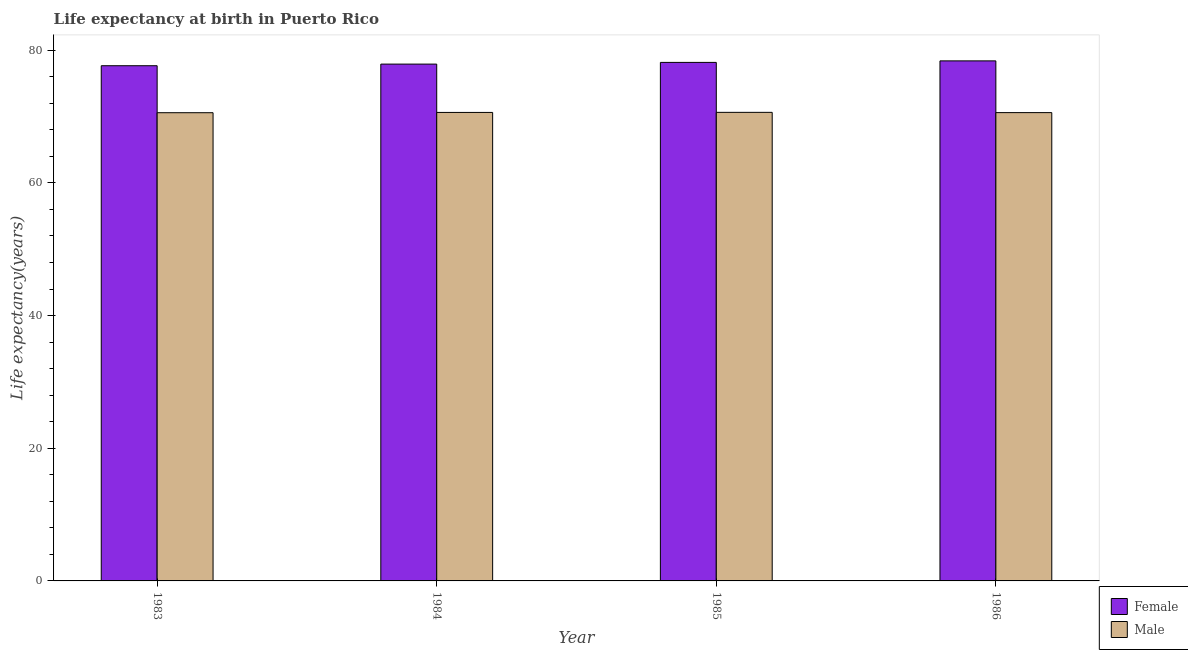How many groups of bars are there?
Your response must be concise. 4. What is the label of the 2nd group of bars from the left?
Your answer should be very brief. 1984. What is the life expectancy(male) in 1984?
Provide a succinct answer. 70.62. Across all years, what is the maximum life expectancy(female)?
Your response must be concise. 78.39. Across all years, what is the minimum life expectancy(male)?
Offer a terse response. 70.58. What is the total life expectancy(male) in the graph?
Give a very brief answer. 282.44. What is the difference between the life expectancy(female) in 1984 and that in 1985?
Provide a succinct answer. -0.26. What is the difference between the life expectancy(male) in 1986 and the life expectancy(female) in 1984?
Offer a very short reply. -0.03. What is the average life expectancy(male) per year?
Provide a succinct answer. 70.61. In the year 1984, what is the difference between the life expectancy(female) and life expectancy(male)?
Your answer should be very brief. 0. What is the ratio of the life expectancy(female) in 1983 to that in 1985?
Make the answer very short. 0.99. Is the difference between the life expectancy(male) in 1985 and 1986 greater than the difference between the life expectancy(female) in 1985 and 1986?
Keep it short and to the point. No. What is the difference between the highest and the second highest life expectancy(female)?
Keep it short and to the point. 0.23. What is the difference between the highest and the lowest life expectancy(male)?
Offer a terse response. 0.05. In how many years, is the life expectancy(male) greater than the average life expectancy(male) taken over all years?
Provide a short and direct response. 2. What does the 1st bar from the left in 1985 represents?
Ensure brevity in your answer.  Female. What does the 1st bar from the right in 1983 represents?
Provide a short and direct response. Male. Are all the bars in the graph horizontal?
Keep it short and to the point. No. What is the difference between two consecutive major ticks on the Y-axis?
Your response must be concise. 20. Are the values on the major ticks of Y-axis written in scientific E-notation?
Offer a very short reply. No. Does the graph contain grids?
Provide a short and direct response. No. How many legend labels are there?
Provide a short and direct response. 2. How are the legend labels stacked?
Offer a very short reply. Vertical. What is the title of the graph?
Ensure brevity in your answer.  Life expectancy at birth in Puerto Rico. What is the label or title of the Y-axis?
Offer a terse response. Life expectancy(years). What is the Life expectancy(years) of Female in 1983?
Ensure brevity in your answer.  77.66. What is the Life expectancy(years) in Male in 1983?
Offer a terse response. 70.58. What is the Life expectancy(years) of Female in 1984?
Provide a succinct answer. 77.91. What is the Life expectancy(years) of Male in 1984?
Give a very brief answer. 70.62. What is the Life expectancy(years) of Female in 1985?
Give a very brief answer. 78.17. What is the Life expectancy(years) of Male in 1985?
Provide a short and direct response. 70.64. What is the Life expectancy(years) of Female in 1986?
Make the answer very short. 78.39. What is the Life expectancy(years) in Male in 1986?
Your answer should be very brief. 70.6. Across all years, what is the maximum Life expectancy(years) of Female?
Make the answer very short. 78.39. Across all years, what is the maximum Life expectancy(years) in Male?
Your answer should be very brief. 70.64. Across all years, what is the minimum Life expectancy(years) in Female?
Offer a very short reply. 77.66. Across all years, what is the minimum Life expectancy(years) in Male?
Keep it short and to the point. 70.58. What is the total Life expectancy(years) of Female in the graph?
Ensure brevity in your answer.  312.13. What is the total Life expectancy(years) of Male in the graph?
Your response must be concise. 282.44. What is the difference between the Life expectancy(years) in Female in 1983 and that in 1984?
Make the answer very short. -0.25. What is the difference between the Life expectancy(years) in Male in 1983 and that in 1984?
Your answer should be very brief. -0.04. What is the difference between the Life expectancy(years) in Female in 1983 and that in 1985?
Your answer should be very brief. -0.5. What is the difference between the Life expectancy(years) in Male in 1983 and that in 1985?
Your answer should be very brief. -0.05. What is the difference between the Life expectancy(years) of Female in 1983 and that in 1986?
Give a very brief answer. -0.73. What is the difference between the Life expectancy(years) of Male in 1983 and that in 1986?
Your answer should be very brief. -0.01. What is the difference between the Life expectancy(years) of Female in 1984 and that in 1985?
Your answer should be compact. -0.26. What is the difference between the Life expectancy(years) of Male in 1984 and that in 1985?
Ensure brevity in your answer.  -0.01. What is the difference between the Life expectancy(years) in Female in 1984 and that in 1986?
Ensure brevity in your answer.  -0.48. What is the difference between the Life expectancy(years) of Male in 1984 and that in 1986?
Provide a succinct answer. 0.03. What is the difference between the Life expectancy(years) in Female in 1985 and that in 1986?
Your answer should be very brief. -0.23. What is the difference between the Life expectancy(years) of Male in 1985 and that in 1986?
Your answer should be compact. 0.04. What is the difference between the Life expectancy(years) of Female in 1983 and the Life expectancy(years) of Male in 1984?
Your answer should be compact. 7.04. What is the difference between the Life expectancy(years) in Female in 1983 and the Life expectancy(years) in Male in 1985?
Give a very brief answer. 7.03. What is the difference between the Life expectancy(years) in Female in 1983 and the Life expectancy(years) in Male in 1986?
Your answer should be very brief. 7.07. What is the difference between the Life expectancy(years) in Female in 1984 and the Life expectancy(years) in Male in 1985?
Your response must be concise. 7.27. What is the difference between the Life expectancy(years) in Female in 1984 and the Life expectancy(years) in Male in 1986?
Keep it short and to the point. 7.31. What is the difference between the Life expectancy(years) of Female in 1985 and the Life expectancy(years) of Male in 1986?
Give a very brief answer. 7.57. What is the average Life expectancy(years) in Female per year?
Provide a succinct answer. 78.03. What is the average Life expectancy(years) of Male per year?
Your answer should be very brief. 70.61. In the year 1983, what is the difference between the Life expectancy(years) of Female and Life expectancy(years) of Male?
Offer a terse response. 7.08. In the year 1984, what is the difference between the Life expectancy(years) in Female and Life expectancy(years) in Male?
Ensure brevity in your answer.  7.29. In the year 1985, what is the difference between the Life expectancy(years) of Female and Life expectancy(years) of Male?
Provide a short and direct response. 7.53. In the year 1986, what is the difference between the Life expectancy(years) of Female and Life expectancy(years) of Male?
Give a very brief answer. 7.8. What is the ratio of the Life expectancy(years) of Male in 1983 to that in 1984?
Your answer should be very brief. 1. What is the ratio of the Life expectancy(years) of Female in 1983 to that in 1986?
Ensure brevity in your answer.  0.99. What is the ratio of the Life expectancy(years) in Male in 1984 to that in 1986?
Offer a terse response. 1. What is the ratio of the Life expectancy(years) in Female in 1985 to that in 1986?
Make the answer very short. 1. What is the difference between the highest and the second highest Life expectancy(years) of Female?
Keep it short and to the point. 0.23. What is the difference between the highest and the second highest Life expectancy(years) of Male?
Your response must be concise. 0.01. What is the difference between the highest and the lowest Life expectancy(years) of Female?
Keep it short and to the point. 0.73. What is the difference between the highest and the lowest Life expectancy(years) in Male?
Keep it short and to the point. 0.05. 